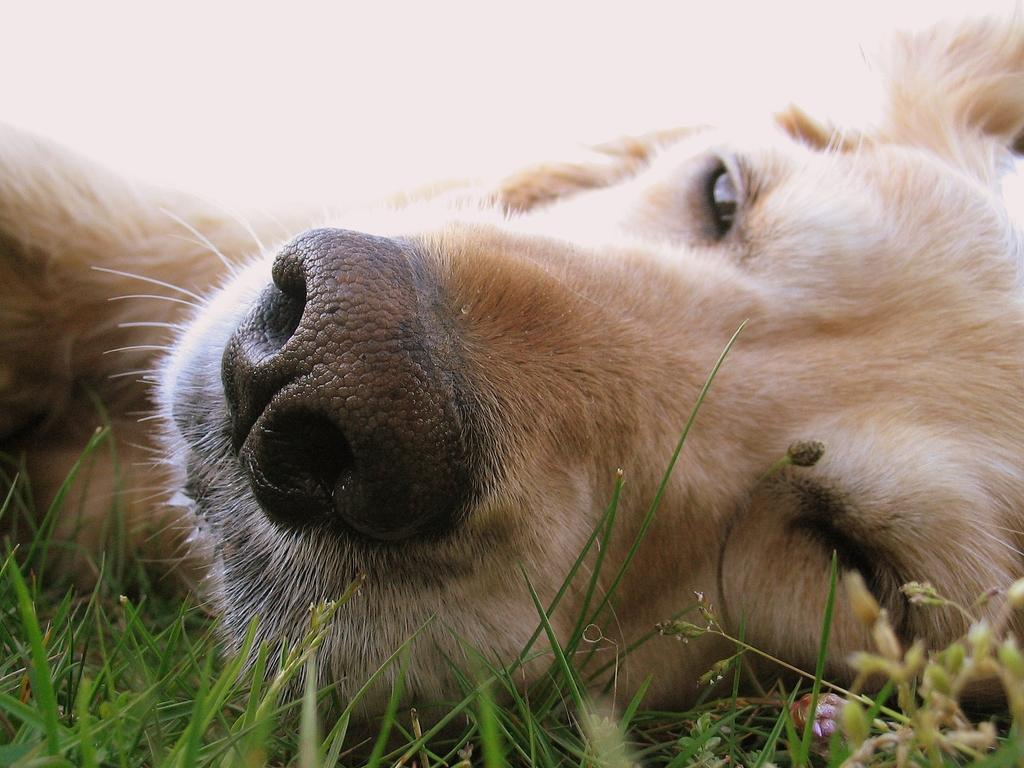What animal can be seen in the picture? There is a dog in the picture. What is the dog lying on? The dog is lying on a grass surface. What is the color of the dog? The dog is cream in color. What color are the dog's nostrils? The dog has black color nostrils. What color is the hair under the dog's face? The dog has white hair under its face. What type of quilt is being used to cover the dog in the image? There is no quilt present in the image; the dog is lying on a grass surface. 